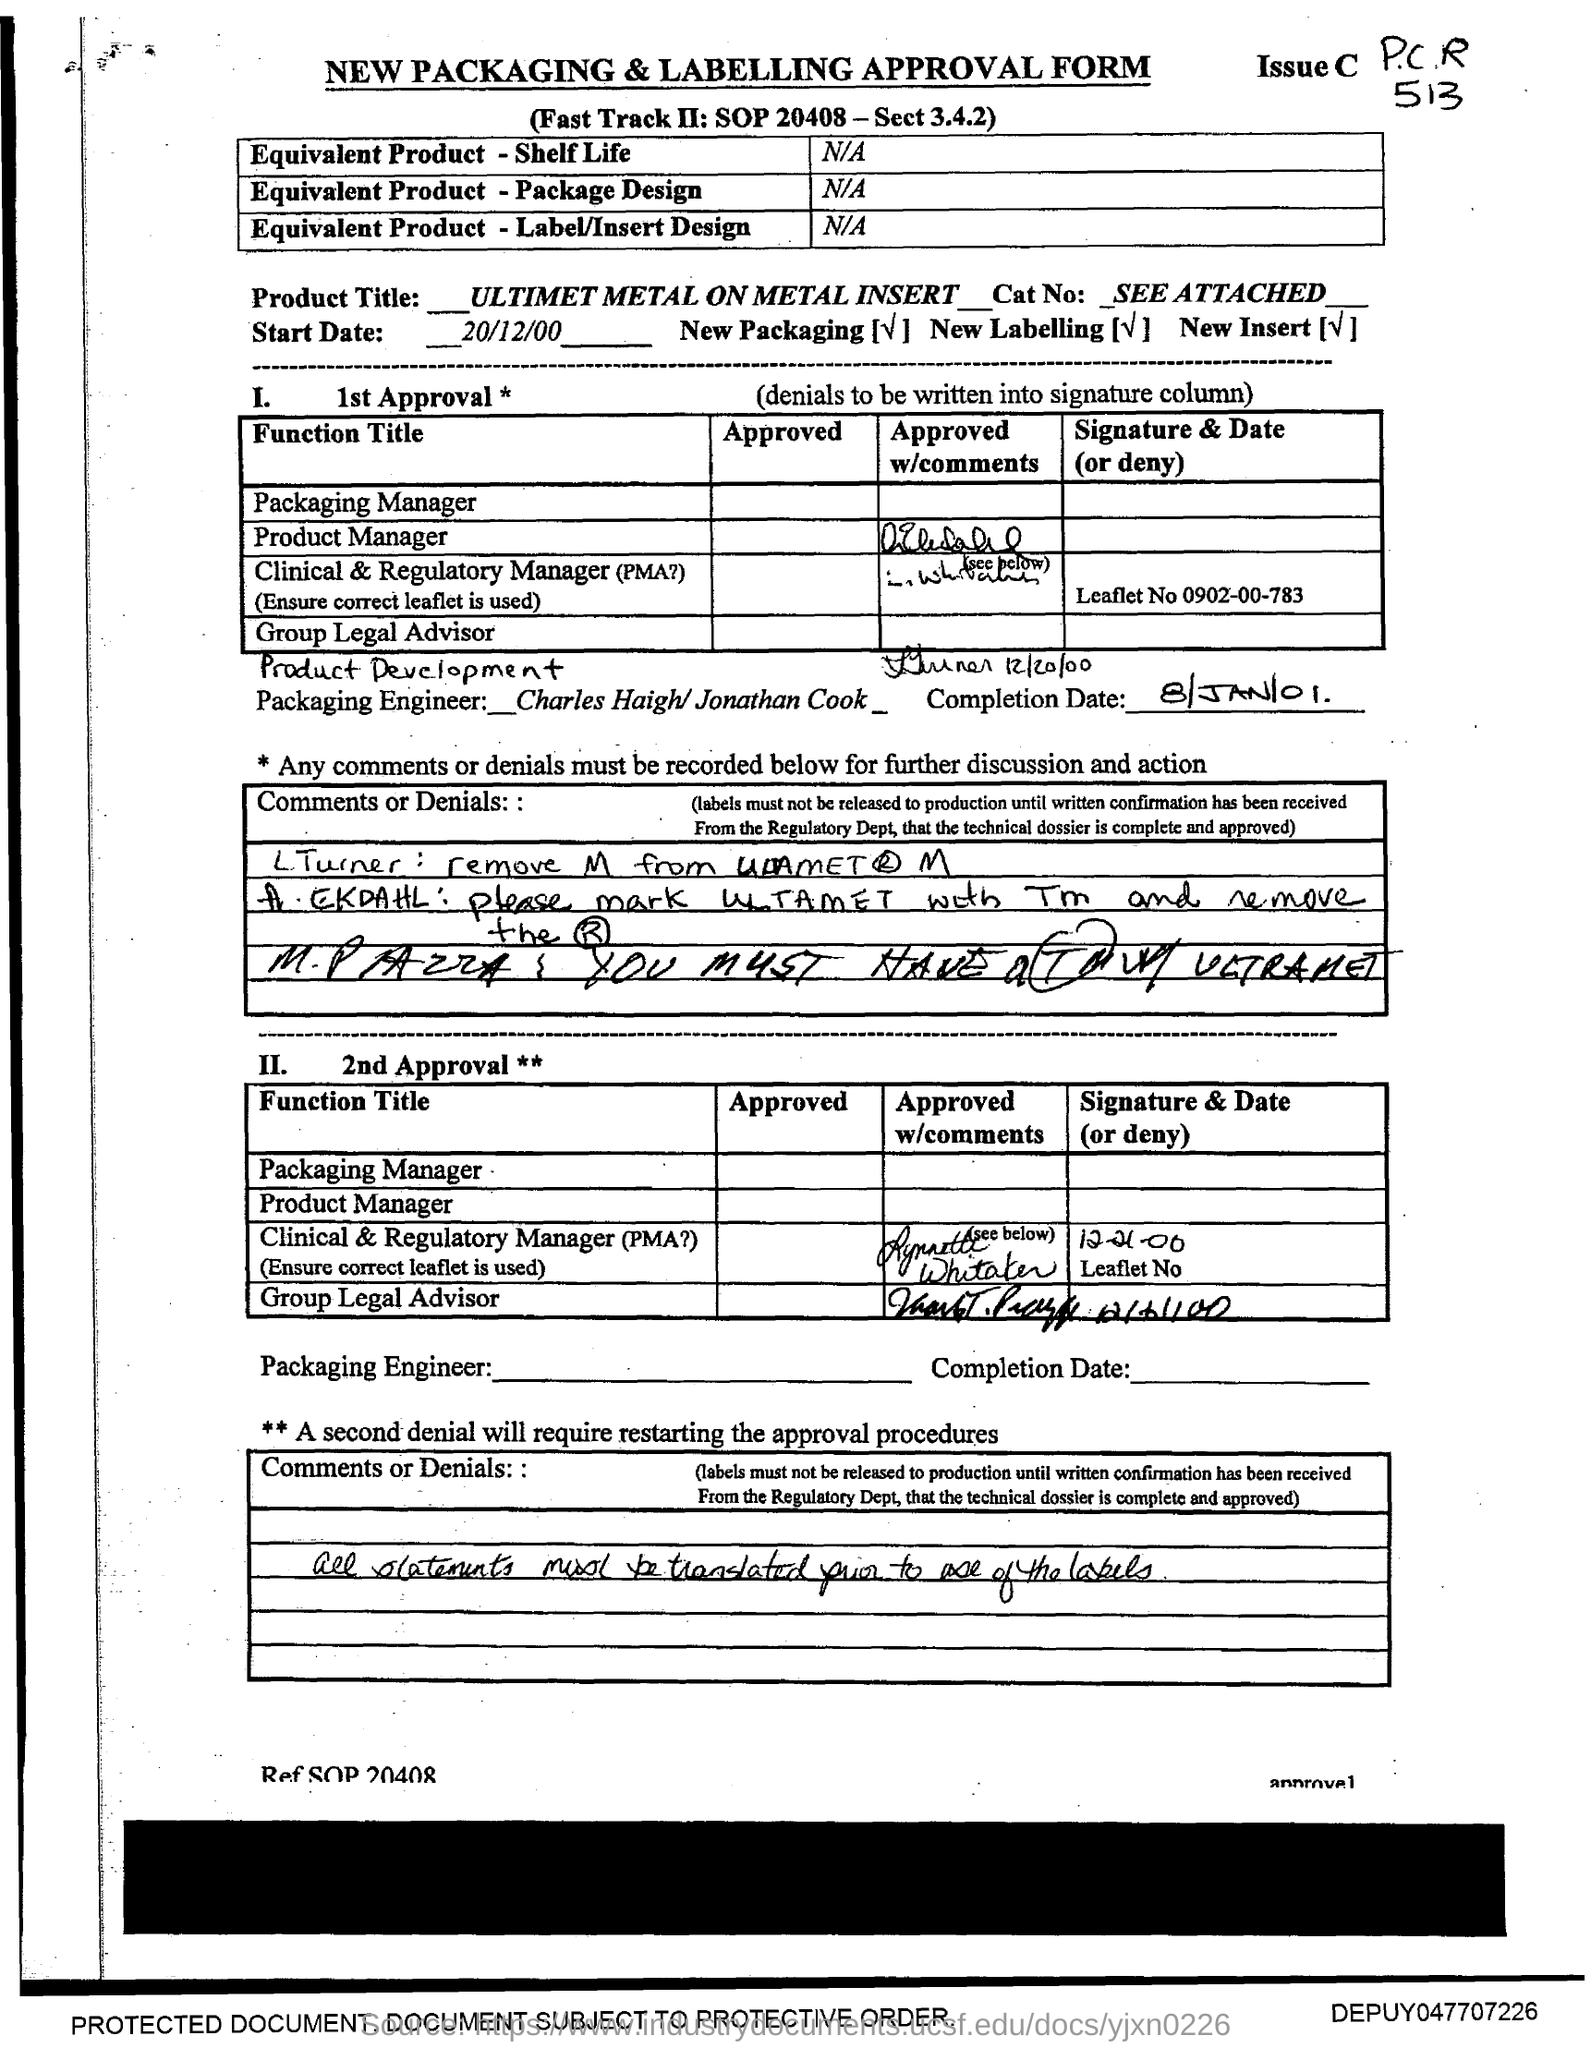What type of form is this?
Your answer should be very brief. NEW PACKAGING & LABELLING APPROVAL FORM. What is the product title mentioned in the form?
Provide a short and direct response. _ULTIMET METAL ON METAL INSERT_. What is the start date given in the form?
Keep it short and to the point. 20/12/00. What is the completion date given in the form?
Ensure brevity in your answer.  8/Jan/01. 